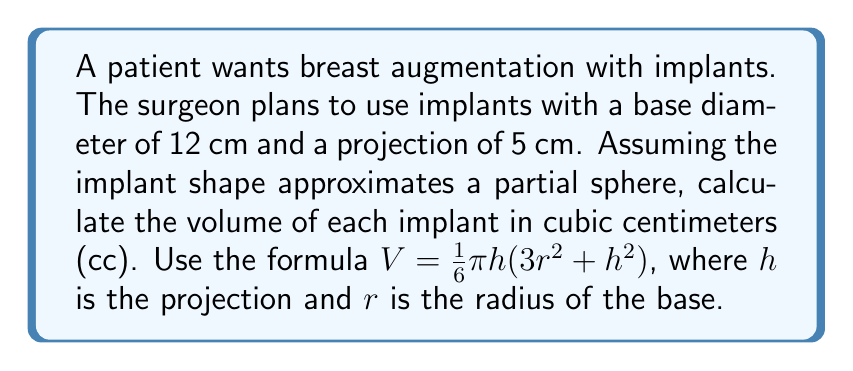Can you solve this math problem? To solve this problem, we'll follow these steps:

1) Identify the given values:
   Base diameter = 12 cm
   Projection (h) = 5 cm

2) Calculate the radius (r) from the base diameter:
   $r = \frac{diameter}{2} = \frac{12}{2} = 6$ cm

3) Substitute the values into the formula:
   $V = \frac{1}{6}\pi h(3r^2 + h^2)$
   $V = \frac{1}{6}\pi \cdot 5(3(6^2) + 5^2)$

4) Simplify the expression inside the parentheses:
   $V = \frac{1}{6}\pi \cdot 5(3(36) + 25)$
   $V = \frac{1}{6}\pi \cdot 5(108 + 25)$
   $V = \frac{1}{6}\pi \cdot 5(133)$

5) Multiply:
   $V = \frac{5}{6}\pi \cdot 133$

6) Calculate the final result:
   $V \approx 347.5$ cc

Therefore, the volume of each implant is approximately 347.5 cc.
Answer: $347.5$ cc 